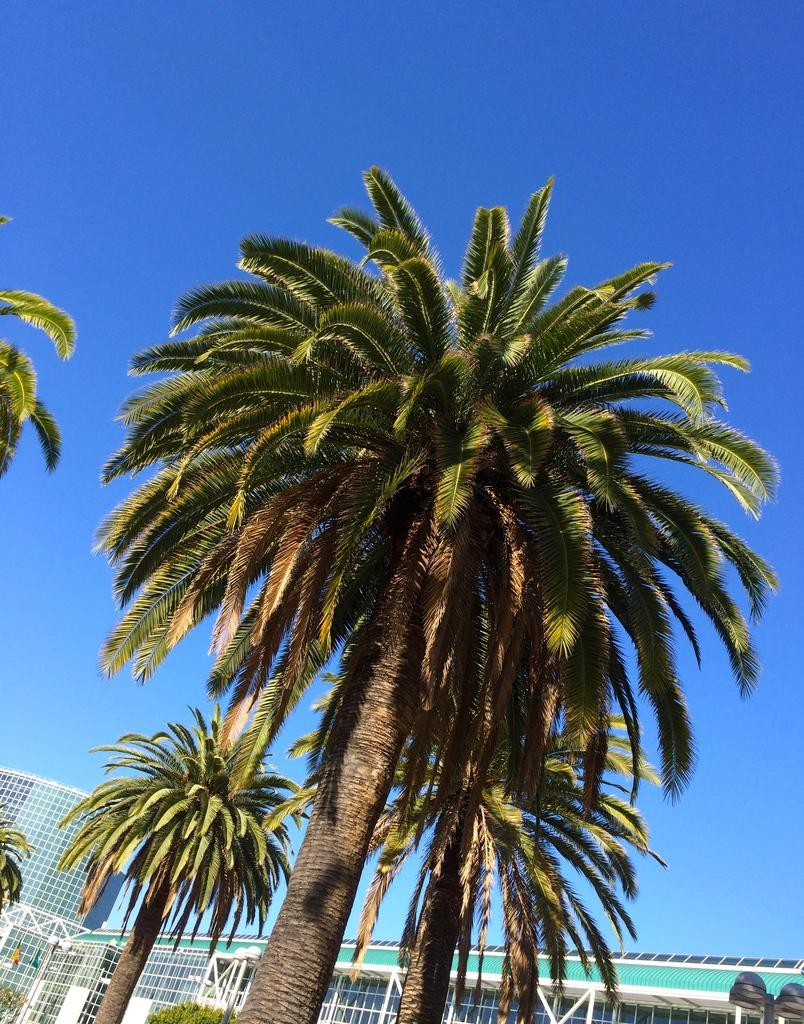What type of structures can be seen in the image? There are buildings in the image. What other natural elements are present in the image? There are trees in the image. What color is the sky in the image? The sky is blue in the image. How does the peace symbol appear in the image? There is no peace symbol present in the image. What type of street can be seen in the image? There is no street visible in the image; it only features buildings, trees, and a blue sky. 